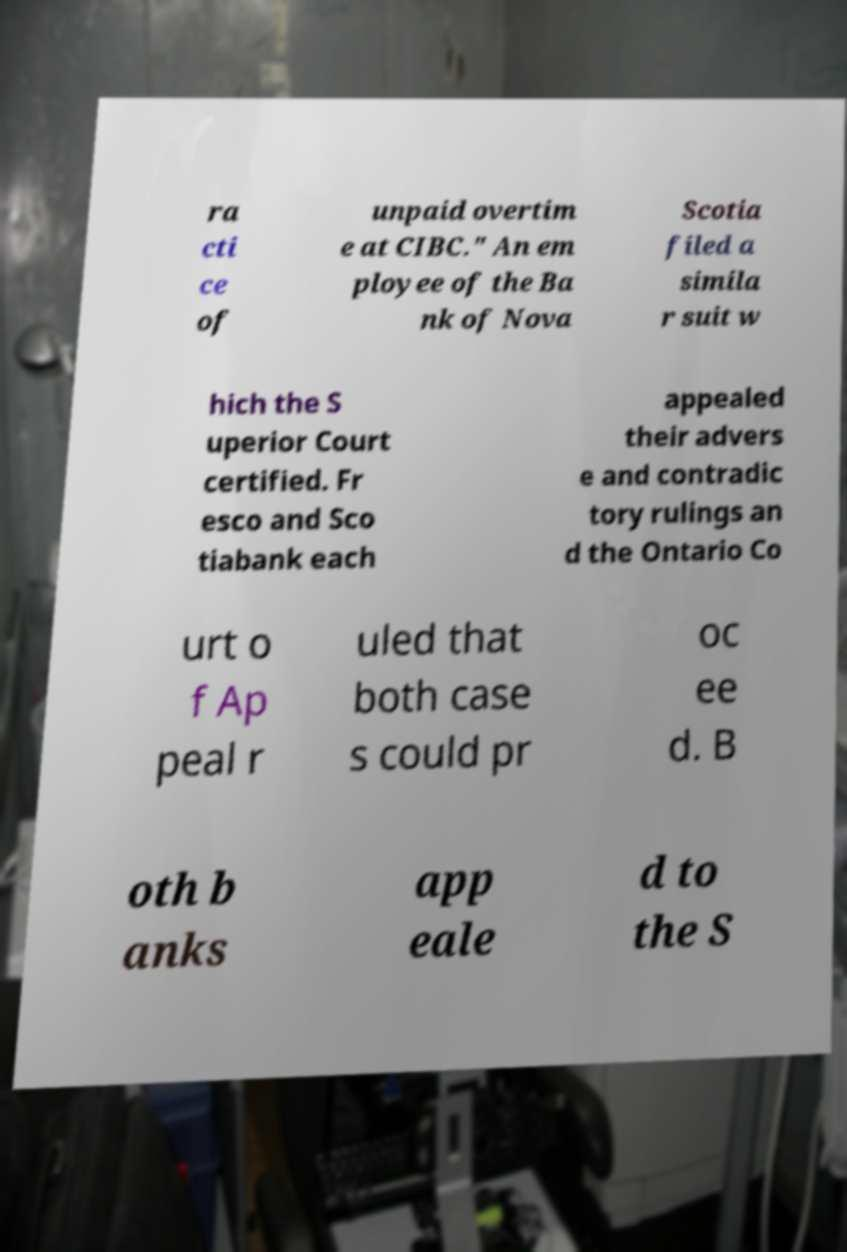For documentation purposes, I need the text within this image transcribed. Could you provide that? ra cti ce of unpaid overtim e at CIBC." An em ployee of the Ba nk of Nova Scotia filed a simila r suit w hich the S uperior Court certified. Fr esco and Sco tiabank each appealed their advers e and contradic tory rulings an d the Ontario Co urt o f Ap peal r uled that both case s could pr oc ee d. B oth b anks app eale d to the S 